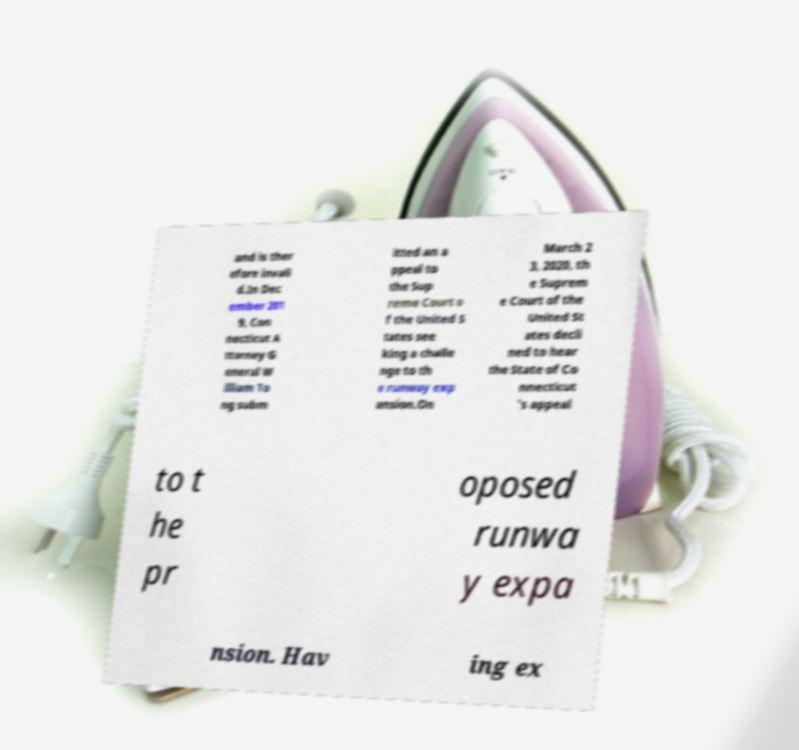Can you accurately transcribe the text from the provided image for me? and is ther efore invali d.In Dec ember 201 9, Con necticut A ttorney G eneral W illiam To ng subm itted an a ppeal to the Sup reme Court o f the United S tates see king a challe nge to th e runway exp ansion.On March 2 3, 2020, th e Suprem e Court of the United St ates decli ned to hear the State of Co nnecticut 's appeal to t he pr oposed runwa y expa nsion. Hav ing ex 